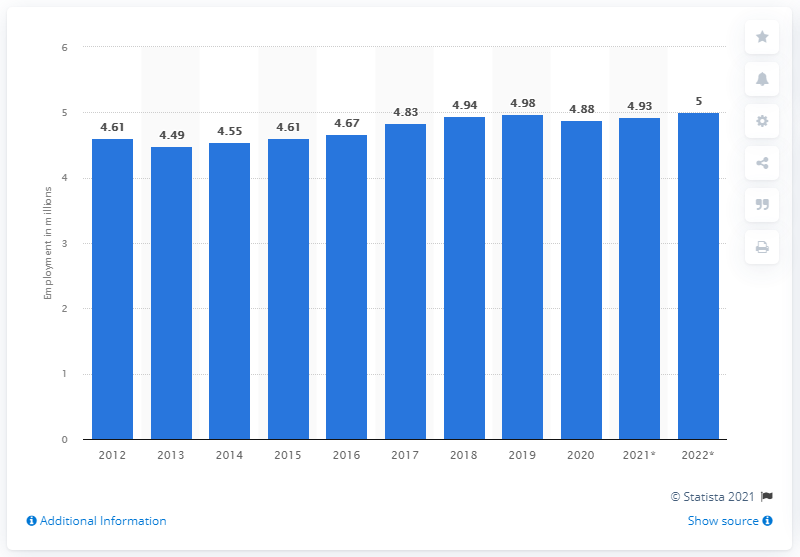Outline some significant characteristics in this image. In 2020, Portugal's employment statistics came to an end. In 2020, the employment statistics of Portugal came to an end. In 2020, approximately 4.88 million people were employed in Portugal. 